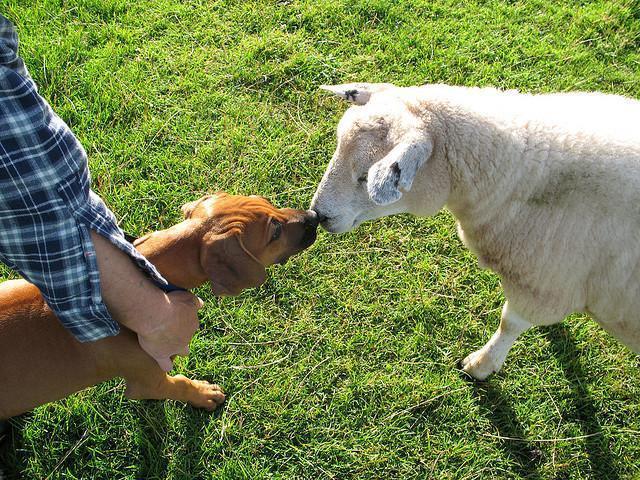Is the caption "The person is touching the sheep." a true representation of the image?
Answer yes or no. No. 